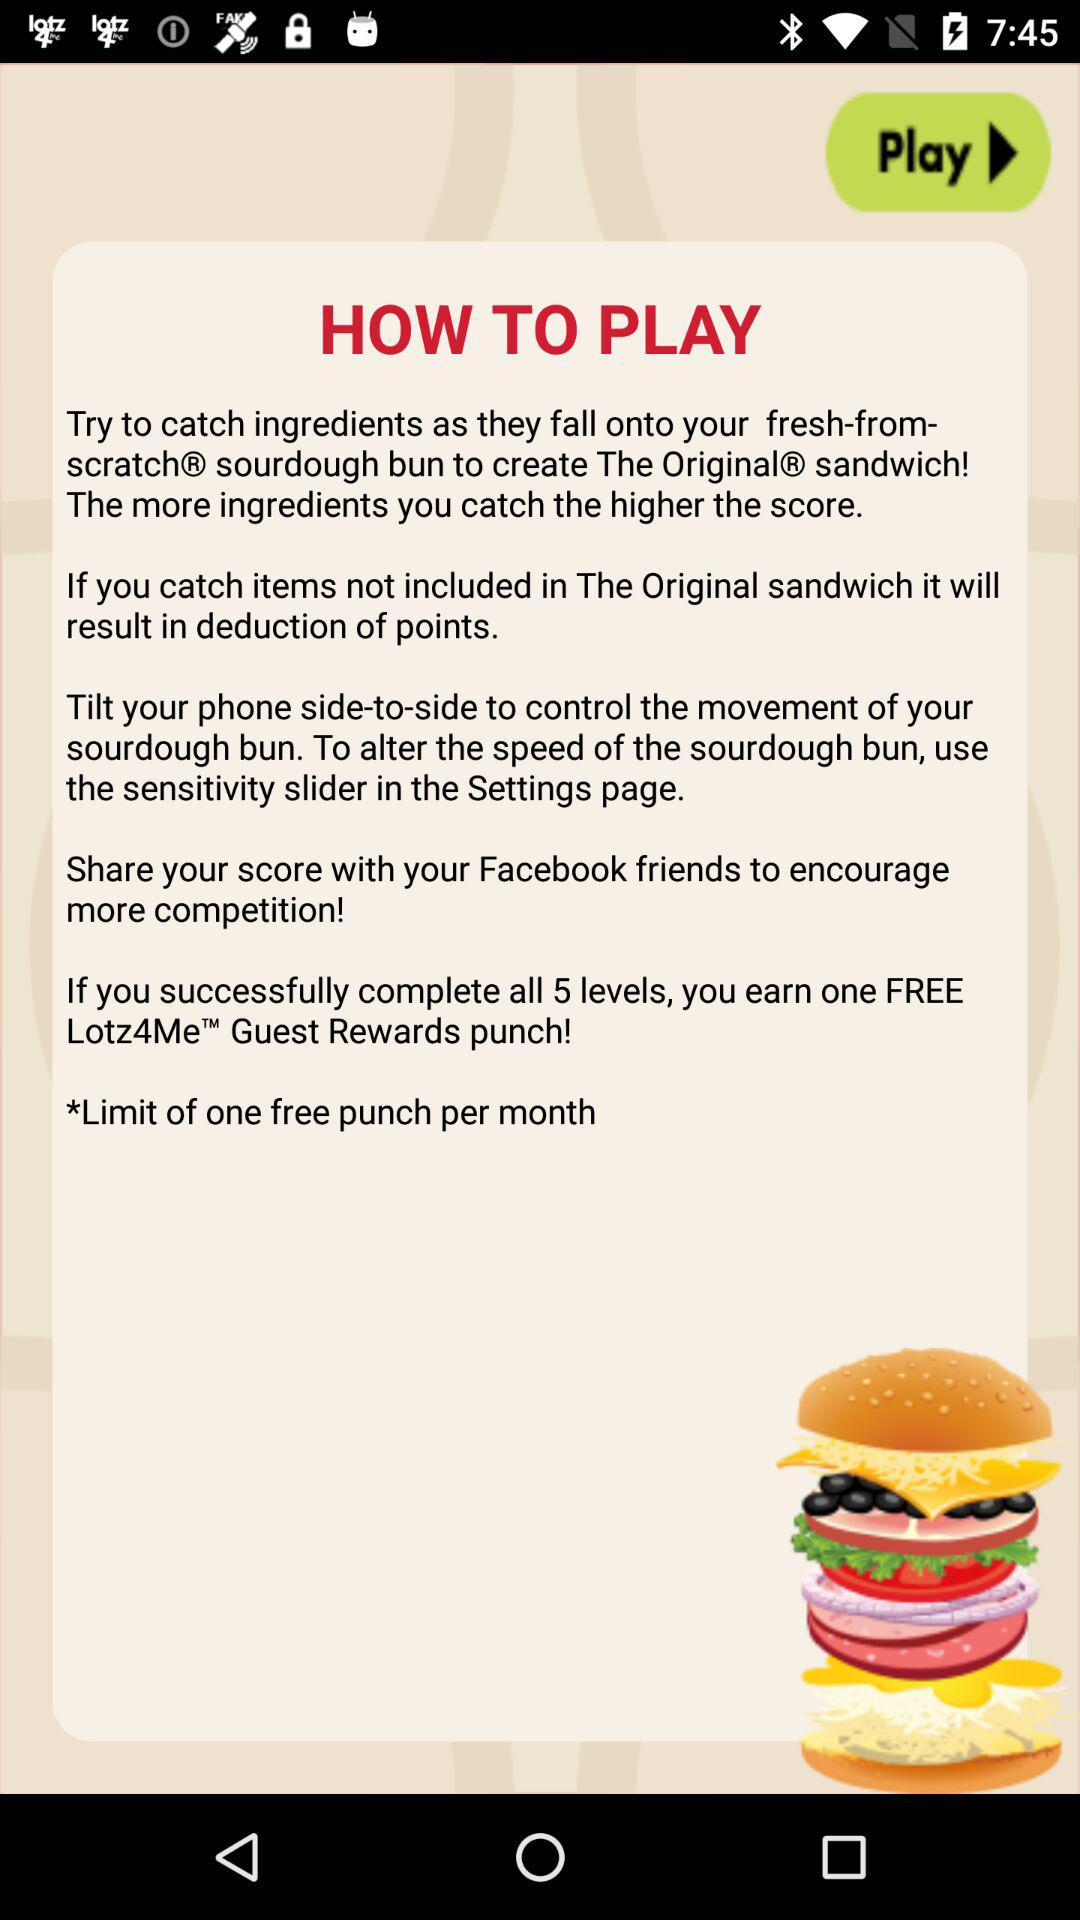What will you earn if you complete all 5 levels?
Answer the question using a single word or phrase. You will earn a FREE Lotz4Me Guest Rewards punch! 